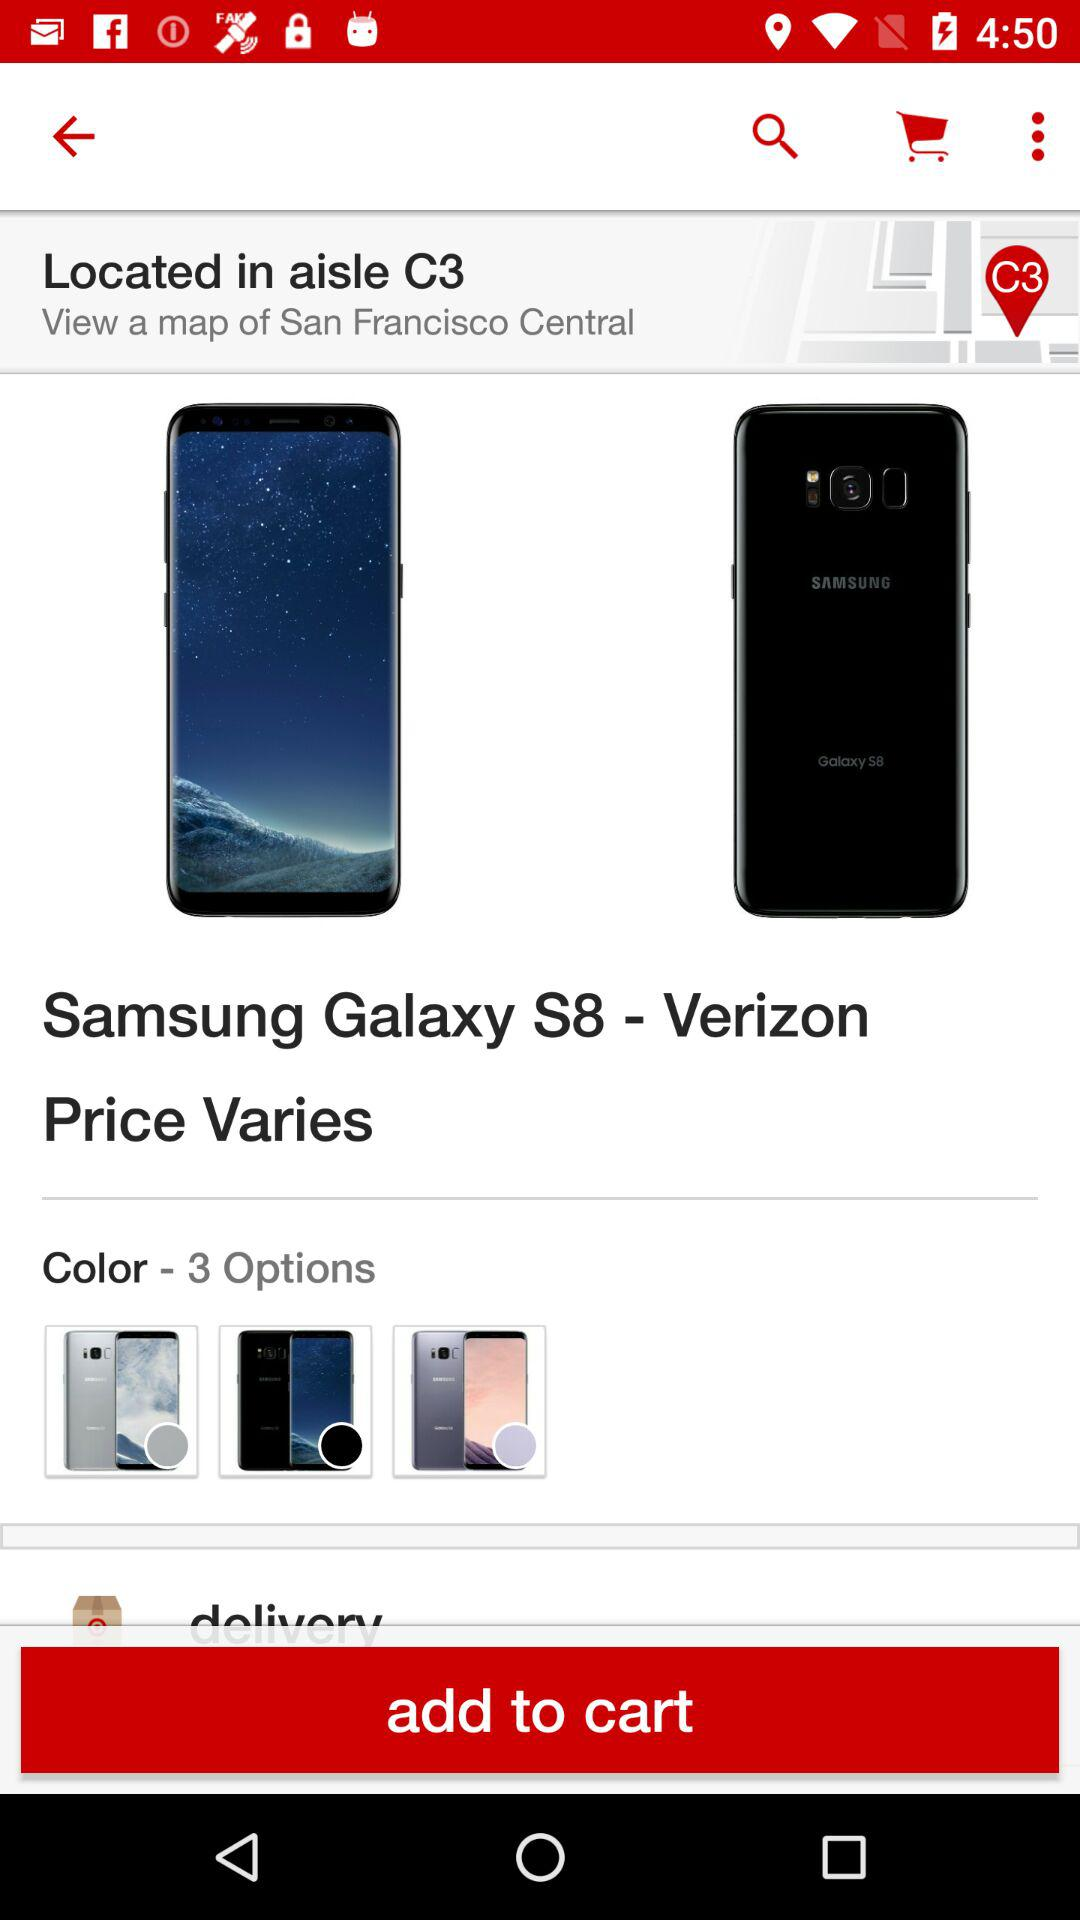How many colors are available? There are 3 available colors. 